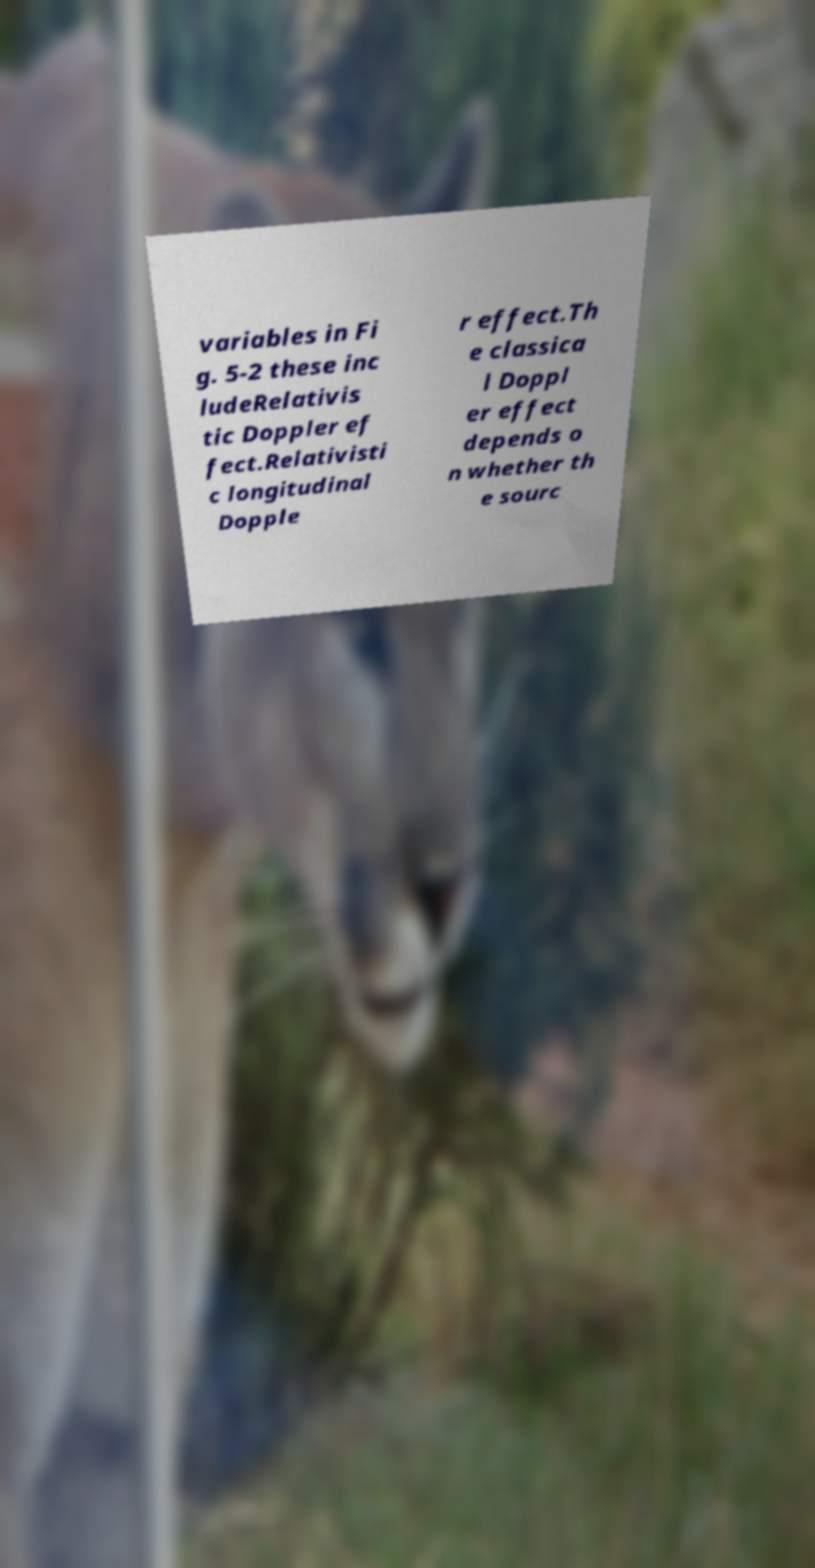Can you read and provide the text displayed in the image?This photo seems to have some interesting text. Can you extract and type it out for me? variables in Fi g. 5-2 these inc ludeRelativis tic Doppler ef fect.Relativisti c longitudinal Dopple r effect.Th e classica l Doppl er effect depends o n whether th e sourc 